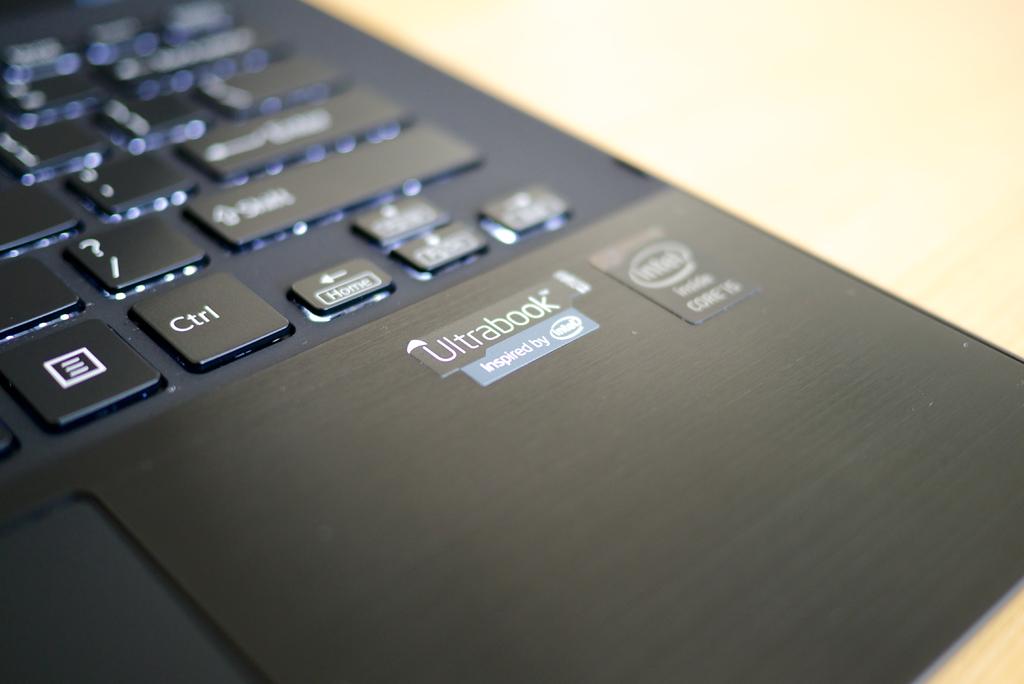What kind of laptop is this?
Offer a terse response. Ultrabook. What kind of processor is inside according to the sticker?
Provide a short and direct response. Intel. 